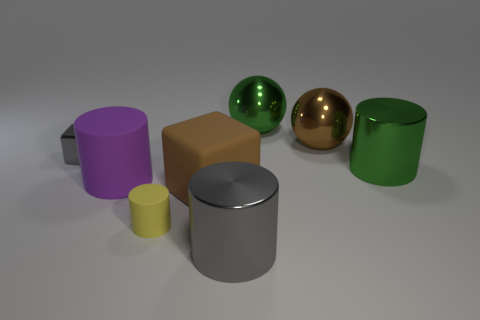If you had to guess, what material are these objects likely made of? Based on their appearance, it is likely that the objects are made of different types of smooth, hard materials like polished metals, glass, or plastic due to their reflective and matte surfaces. 